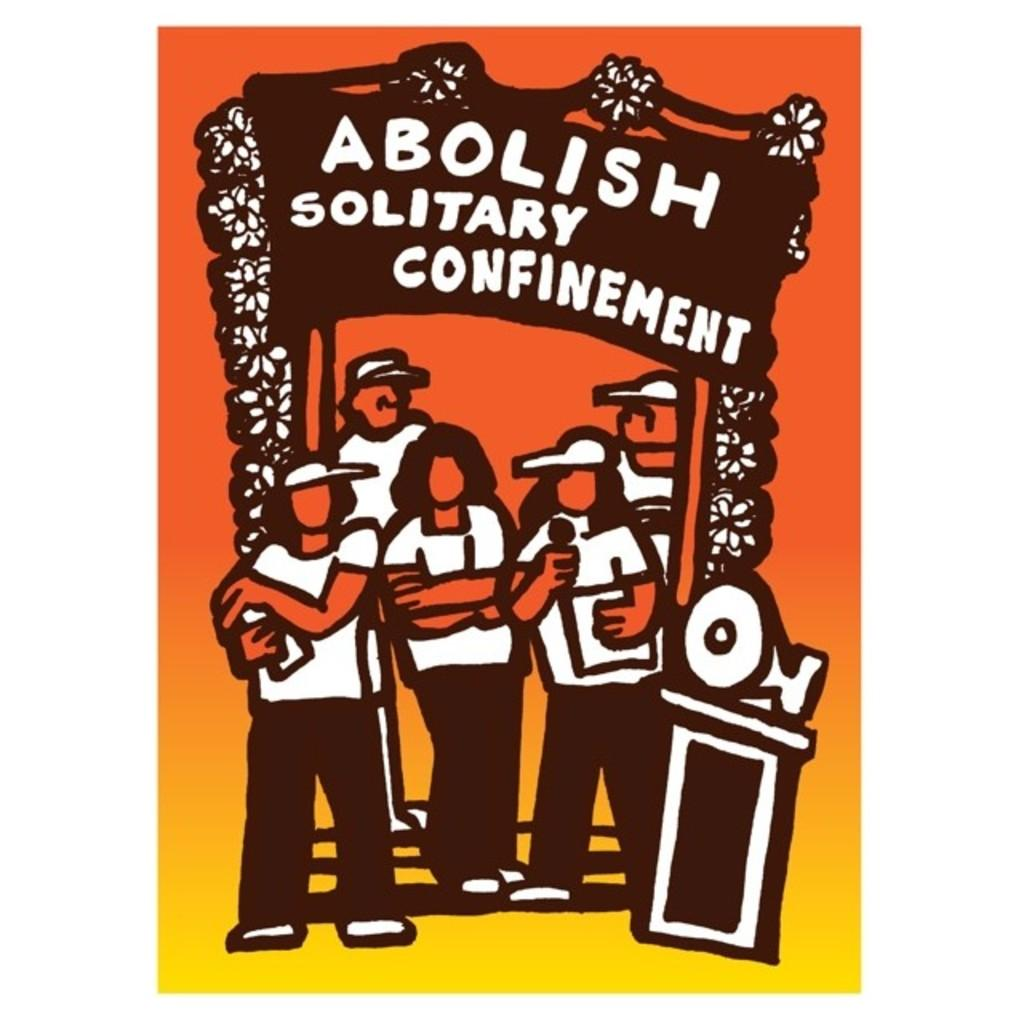<image>
Render a clear and concise summary of the photo. Five people at an "Abolish Solitary Confinement" rally 